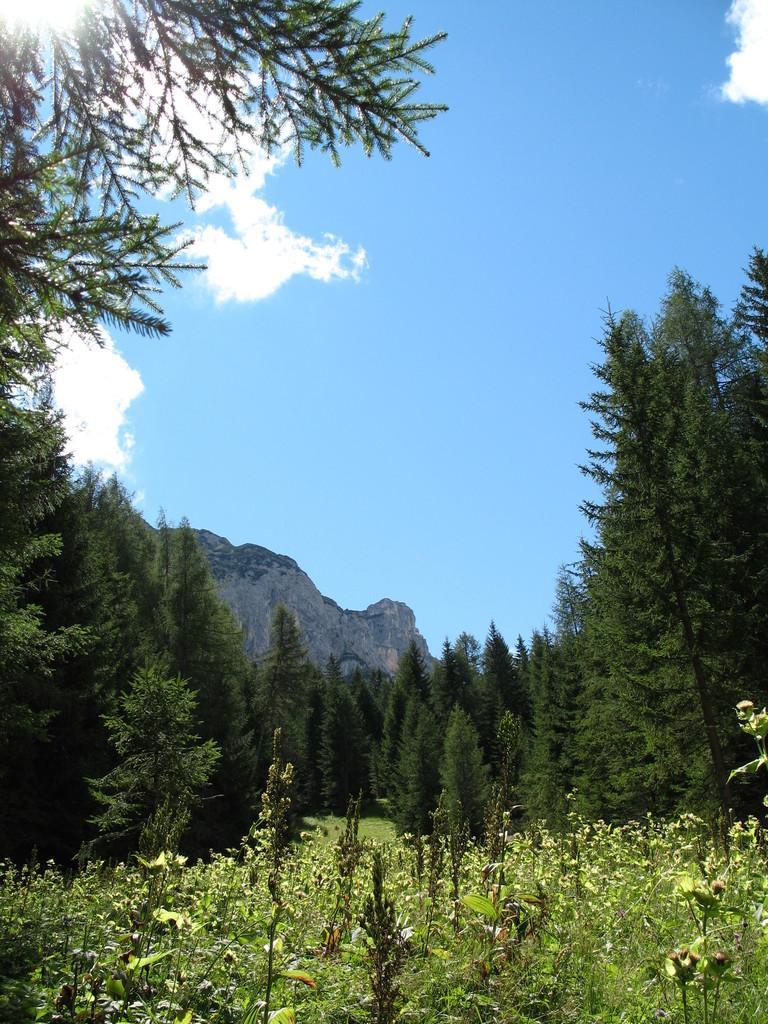Please provide a concise description of this image. In this image there is grass on the surface. At the background there are trees, mountains and sky. 